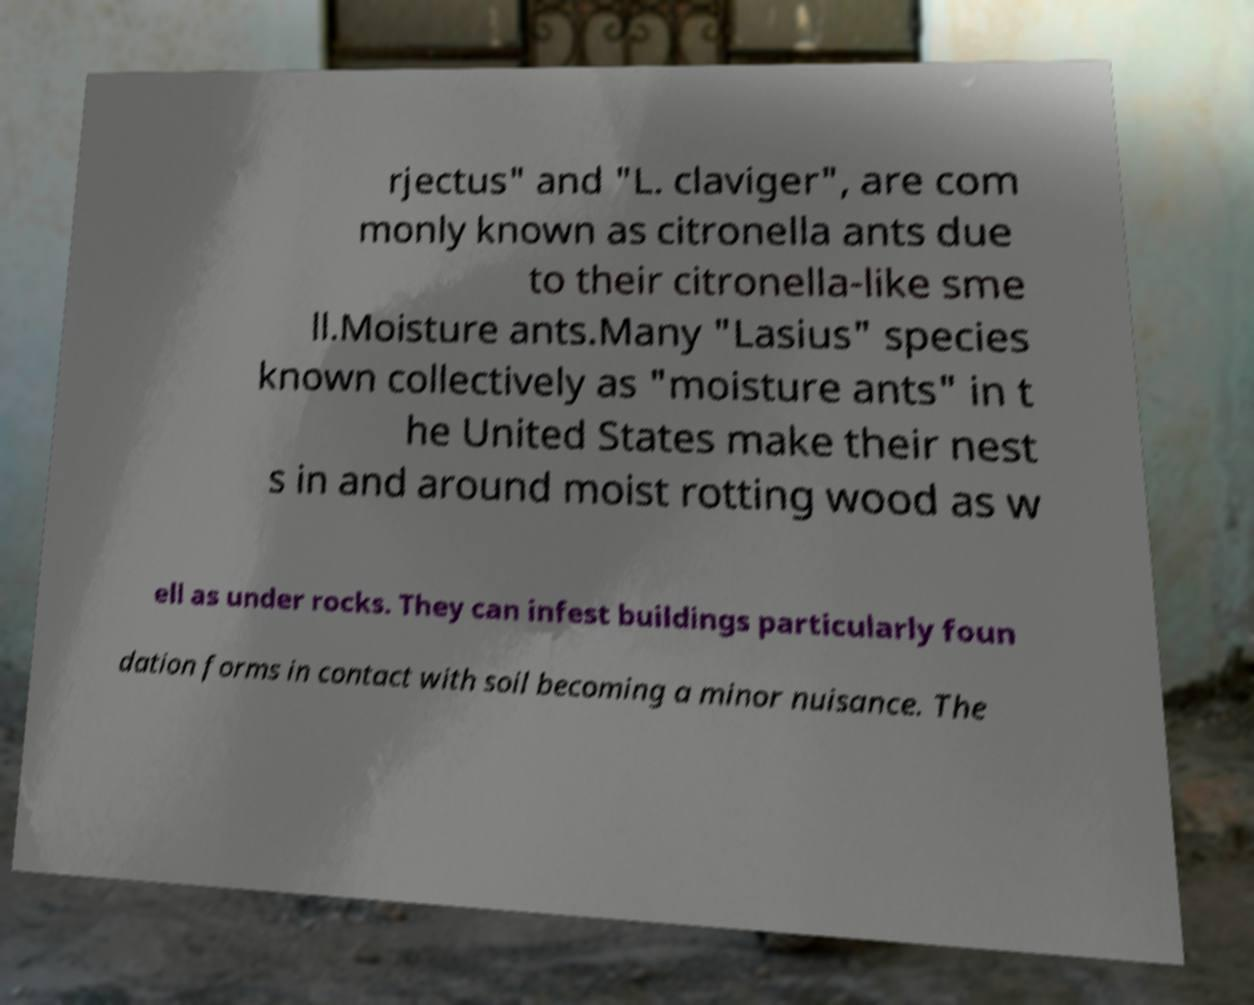Please read and relay the text visible in this image. What does it say? rjectus" and "L. claviger", are com monly known as citronella ants due to their citronella-like sme ll.Moisture ants.Many "Lasius" species known collectively as "moisture ants" in t he United States make their nest s in and around moist rotting wood as w ell as under rocks. They can infest buildings particularly foun dation forms in contact with soil becoming a minor nuisance. The 